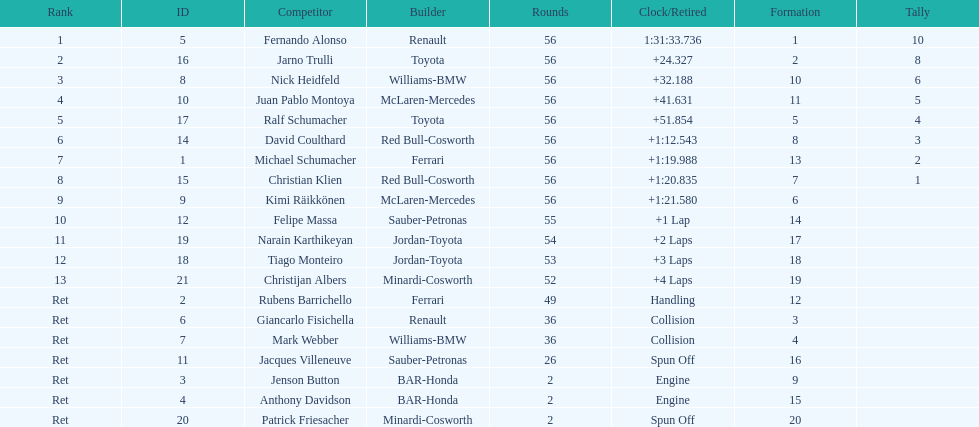How many drivers ended the race early because of engine problems? 2. 